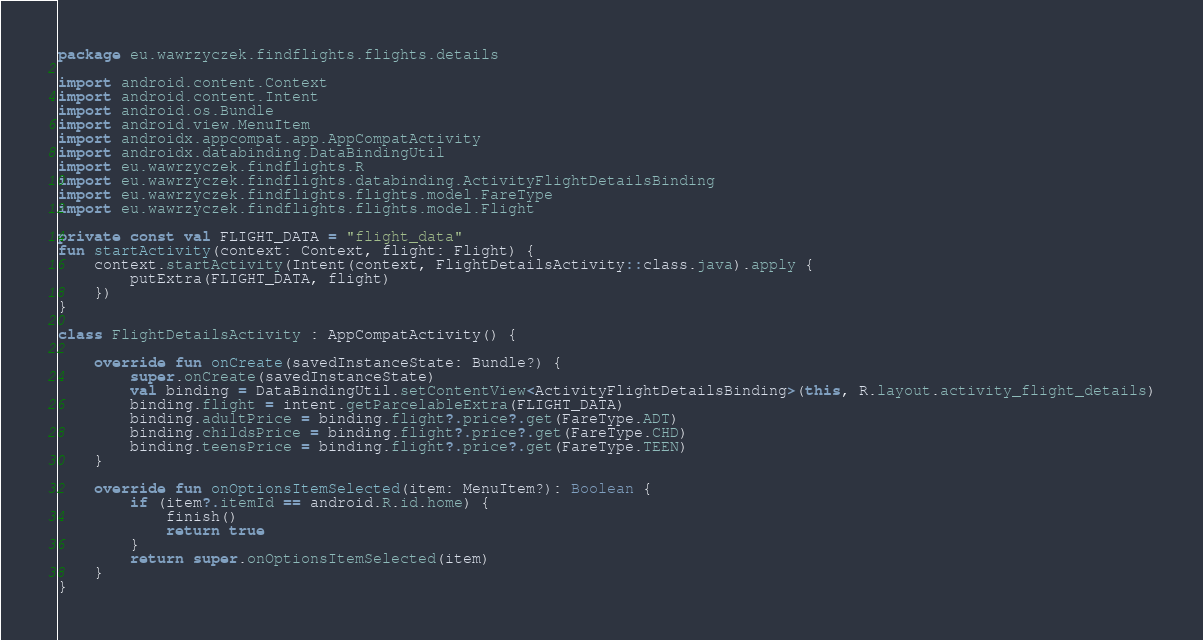Convert code to text. <code><loc_0><loc_0><loc_500><loc_500><_Kotlin_>package eu.wawrzyczek.findflights.flights.details

import android.content.Context
import android.content.Intent
import android.os.Bundle
import android.view.MenuItem
import androidx.appcompat.app.AppCompatActivity
import androidx.databinding.DataBindingUtil
import eu.wawrzyczek.findflights.R
import eu.wawrzyczek.findflights.databinding.ActivityFlightDetailsBinding
import eu.wawrzyczek.findflights.flights.model.FareType
import eu.wawrzyczek.findflights.flights.model.Flight

private const val FLIGHT_DATA = "flight_data"
fun startActivity(context: Context, flight: Flight) {
    context.startActivity(Intent(context, FlightDetailsActivity::class.java).apply {
        putExtra(FLIGHT_DATA, flight)
    })
}

class FlightDetailsActivity : AppCompatActivity() {

    override fun onCreate(savedInstanceState: Bundle?) {
        super.onCreate(savedInstanceState)
        val binding = DataBindingUtil.setContentView<ActivityFlightDetailsBinding>(this, R.layout.activity_flight_details)
        binding.flight = intent.getParcelableExtra(FLIGHT_DATA)
        binding.adultPrice = binding.flight?.price?.get(FareType.ADT)
        binding.childsPrice = binding.flight?.price?.get(FareType.CHD)
        binding.teensPrice = binding.flight?.price?.get(FareType.TEEN)
    }

    override fun onOptionsItemSelected(item: MenuItem?): Boolean {
        if (item?.itemId == android.R.id.home) {
            finish()
            return true
        }
        return super.onOptionsItemSelected(item)
    }
}</code> 